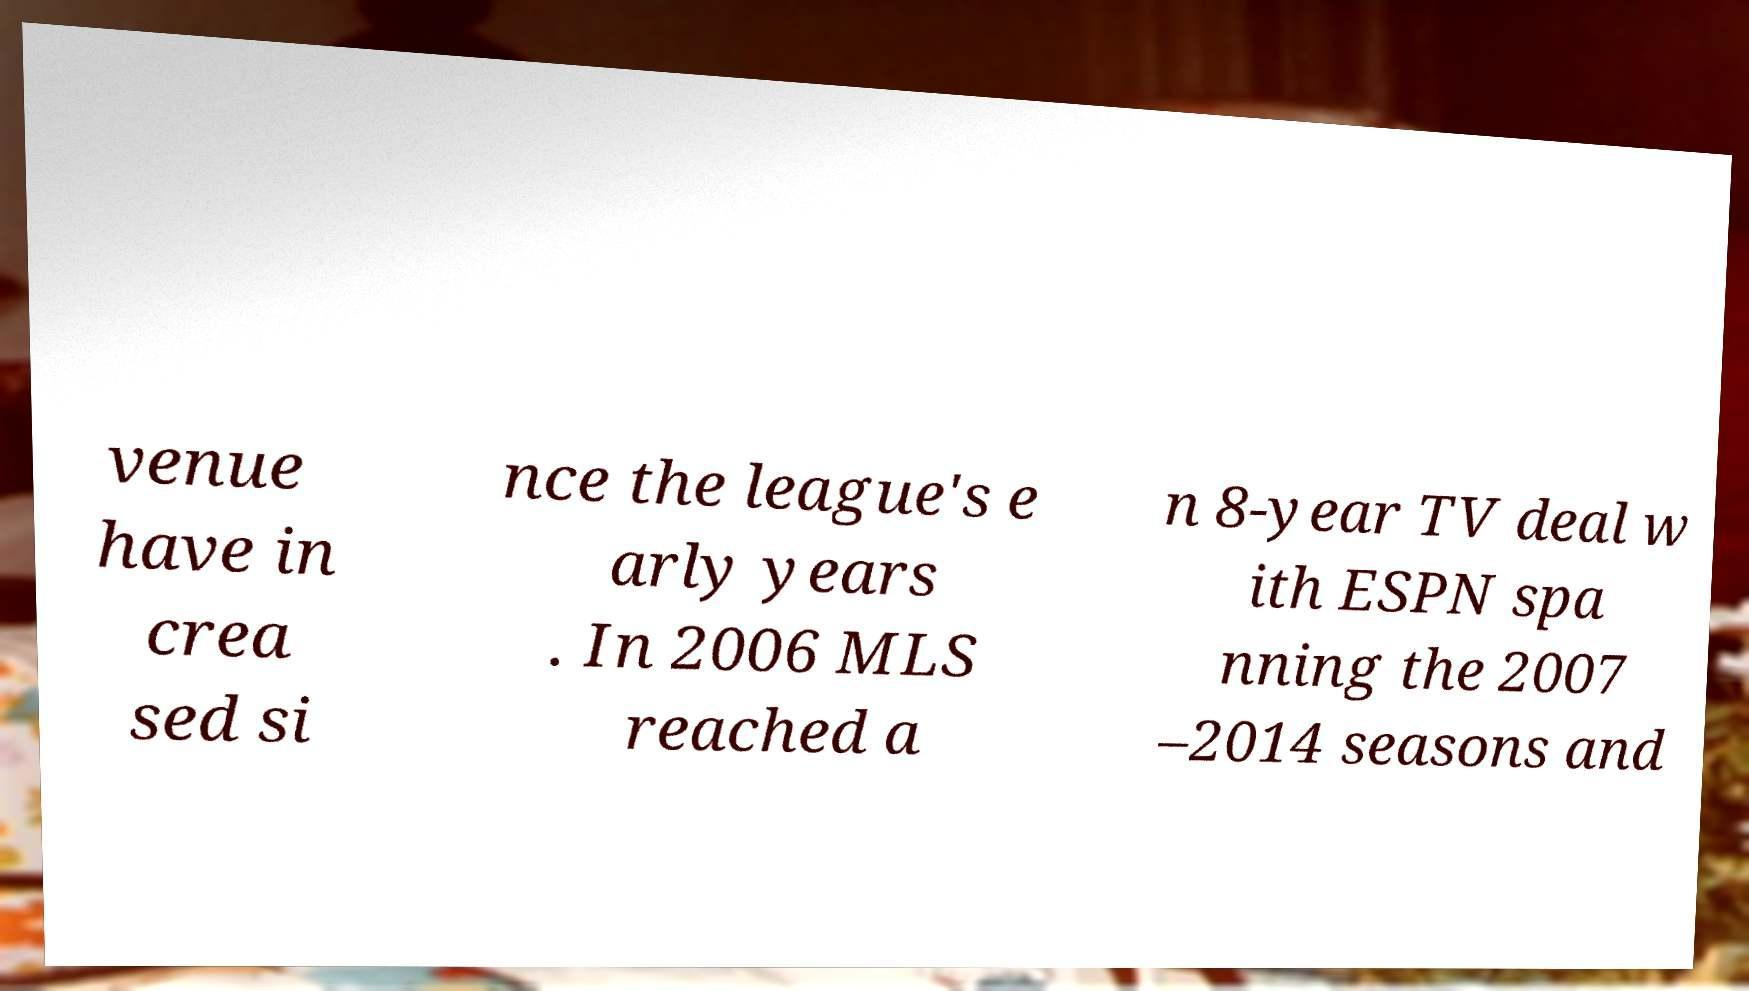There's text embedded in this image that I need extracted. Can you transcribe it verbatim? venue have in crea sed si nce the league's e arly years . In 2006 MLS reached a n 8-year TV deal w ith ESPN spa nning the 2007 –2014 seasons and 